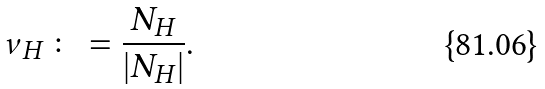<formula> <loc_0><loc_0><loc_500><loc_500>\nu _ { H } \colon = \frac { N _ { H } } { | N _ { H } | } .</formula> 